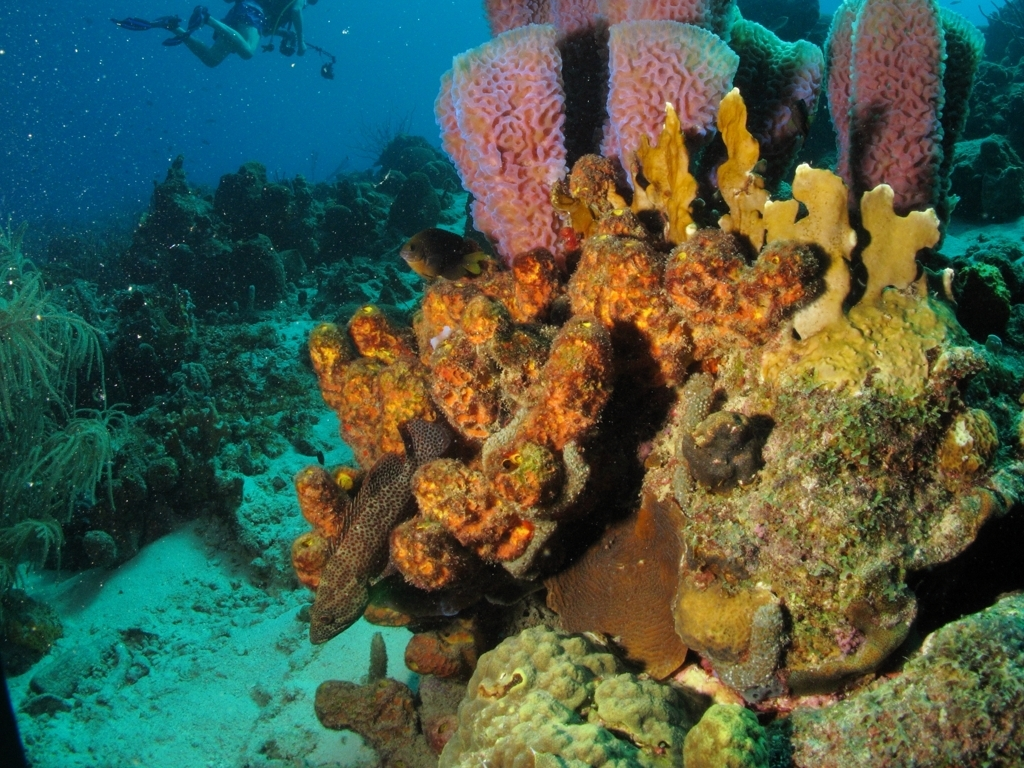Are the colors in the image rich and vivid?
A. No
B. Yes
Answer with the option's letter from the given choices directly.
 B. 